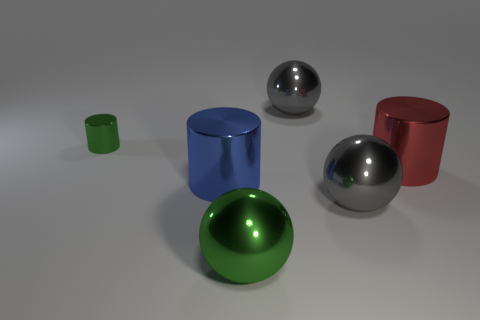How many things are either green objects or cyan matte cylinders?
Your response must be concise. 2. There is a metal cylinder in front of the large red cylinder; is it the same size as the green object behind the red metal thing?
Provide a short and direct response. No. What number of other things are there of the same size as the green cylinder?
Ensure brevity in your answer.  0. What number of things are balls that are behind the green shiny cylinder or objects that are behind the tiny cylinder?
Make the answer very short. 1. Are the big red object and the green thing behind the large green metallic object made of the same material?
Keep it short and to the point. Yes. What number of other objects are there of the same shape as the big green shiny object?
Give a very brief answer. 2. What material is the large cylinder that is on the left side of the gray ball that is in front of the gray metallic thing that is behind the small green metallic cylinder?
Ensure brevity in your answer.  Metal. Are there the same number of tiny objects right of the tiny shiny cylinder and large shiny things?
Your response must be concise. No. Do the green thing in front of the small metal cylinder and the green object that is behind the red cylinder have the same shape?
Offer a very short reply. No. Is the number of cylinders to the left of the large green thing less than the number of shiny cylinders?
Provide a short and direct response. Yes. 